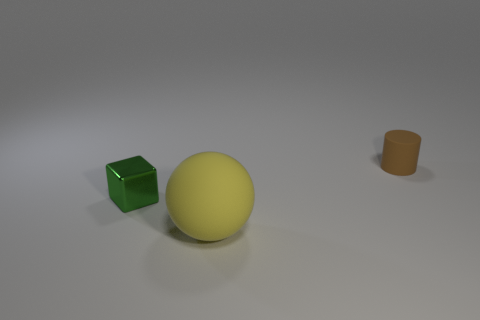What number of objects are either matte objects behind the big yellow rubber thing or tiny objects that are on the left side of the small matte object?
Give a very brief answer. 2. Is the size of the cylinder the same as the yellow rubber thing?
Offer a very short reply. No. Are there any other things that are the same size as the yellow matte thing?
Give a very brief answer. No. There is a rubber thing that is to the right of the big yellow matte sphere; does it have the same shape as the object that is in front of the cube?
Offer a very short reply. No. What size is the yellow rubber sphere?
Your answer should be very brief. Large. There is a small thing in front of the rubber object on the right side of the matte thing in front of the tiny brown matte thing; what is its material?
Your answer should be compact. Metal. What number of other objects are there of the same color as the matte cylinder?
Offer a terse response. 0. How many green objects are large matte cylinders or matte balls?
Offer a very short reply. 0. What is the material of the small thing to the right of the yellow matte sphere?
Ensure brevity in your answer.  Rubber. Is the material of the thing that is in front of the green thing the same as the cylinder?
Keep it short and to the point. Yes. 